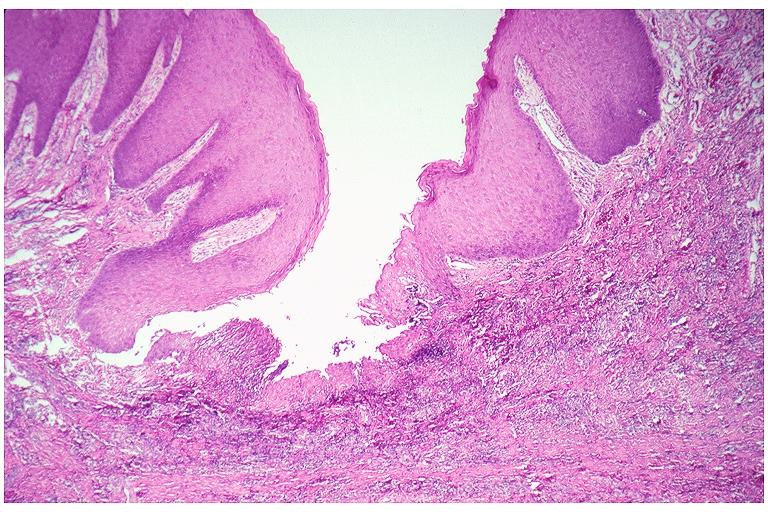what does this image show?
Answer the question using a single word or phrase. Epulis fissuratum 